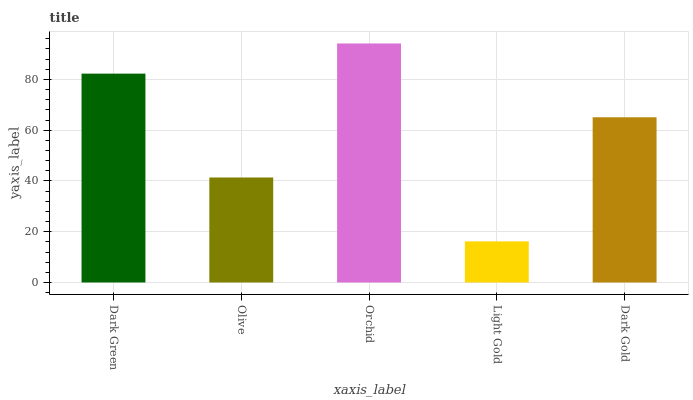Is Olive the minimum?
Answer yes or no. No. Is Olive the maximum?
Answer yes or no. No. Is Dark Green greater than Olive?
Answer yes or no. Yes. Is Olive less than Dark Green?
Answer yes or no. Yes. Is Olive greater than Dark Green?
Answer yes or no. No. Is Dark Green less than Olive?
Answer yes or no. No. Is Dark Gold the high median?
Answer yes or no. Yes. Is Dark Gold the low median?
Answer yes or no. Yes. Is Orchid the high median?
Answer yes or no. No. Is Light Gold the low median?
Answer yes or no. No. 